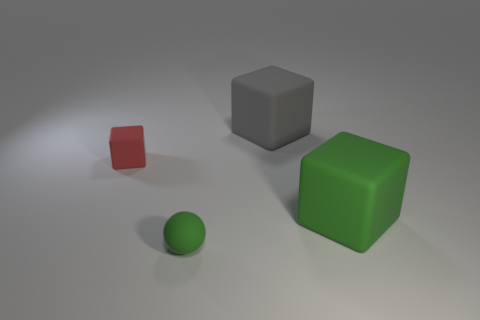Is the red cube the same size as the green rubber cube?
Provide a short and direct response. No. Is there anything else that has the same shape as the tiny green object?
Offer a terse response. No. Does the large object in front of the gray cube have the same color as the ball?
Keep it short and to the point. Yes. What number of things are both in front of the large gray matte cube and behind the matte ball?
Provide a short and direct response. 2. There is a green object that is behind the green object on the left side of the big matte cube behind the red rubber cube; what size is it?
Your answer should be very brief. Large. What number of other things are the same color as the tiny matte cube?
Offer a terse response. 0. What is the shape of the green rubber thing that is the same size as the gray thing?
Make the answer very short. Cube. There is a green thing on the right side of the gray cube; what size is it?
Your answer should be compact. Large. There is a large rubber cube that is in front of the big gray object; is its color the same as the tiny object in front of the big green rubber block?
Make the answer very short. Yes. There is a cube to the right of the big gray thing that is on the right side of the tiny matte object on the left side of the green ball; what is it made of?
Make the answer very short. Rubber. 